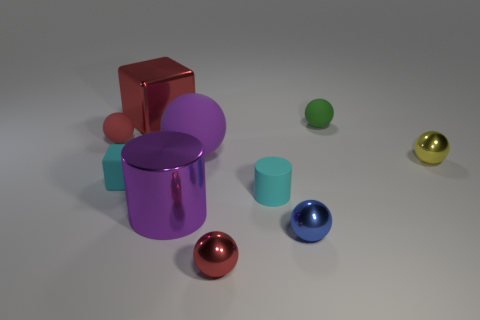There is a big rubber thing that is the same shape as the yellow metallic thing; what color is it?
Ensure brevity in your answer.  Purple. Do the cylinder that is left of the small cylinder and the matte cube have the same color?
Your answer should be compact. No. How many things are either metallic objects that are behind the yellow metal object or red metal cubes?
Offer a terse response. 1. What material is the tiny red sphere that is in front of the small red object that is behind the tiny metallic thing right of the blue metal object made of?
Offer a very short reply. Metal. Is the number of rubber blocks behind the tiny cube greater than the number of green objects in front of the red shiny ball?
Offer a very short reply. No. What number of spheres are tiny red things or tiny red matte things?
Offer a terse response. 2. What number of big cylinders are on the left side of the small ball that is behind the small red object behind the large ball?
Provide a succinct answer. 1. What is the material of the tiny block that is the same color as the small rubber cylinder?
Your answer should be very brief. Rubber. Is the number of small green matte balls greater than the number of tiny red spheres?
Provide a succinct answer. No. Is the size of the blue metal thing the same as the yellow metallic ball?
Your answer should be very brief. Yes. 